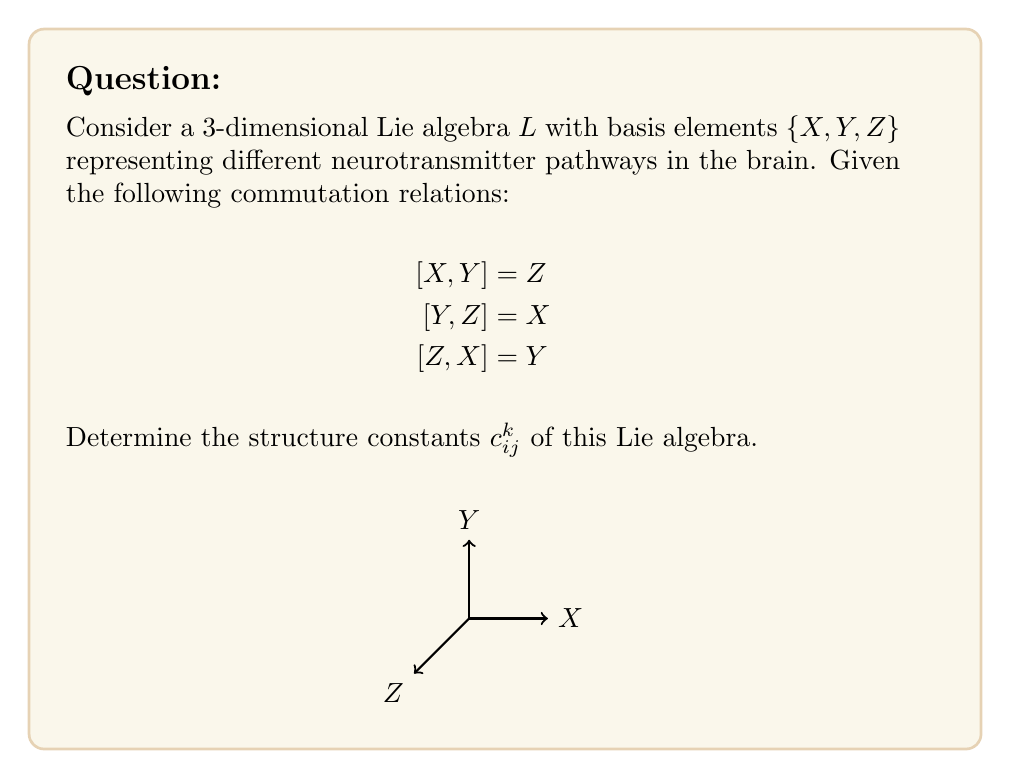Show me your answer to this math problem. To find the structure constants, we follow these steps:

1) The structure constants $c_{ij}^k$ are defined by the equation:

   $$[e_i, e_j] = \sum_k c_{ij}^k e_k$$

   where $e_i, e_j, e_k$ are basis elements.

2) In our case, we have $e_1 = X$, $e_2 = Y$, and $e_3 = Z$.

3) Let's analyze each commutation relation:

   a) $[X, Y] = Z$ implies $c_{12}^3 = 1$ and $c_{12}^1 = c_{12}^2 = 0$
   b) $[Y, Z] = X$ implies $c_{23}^1 = 1$ and $c_{23}^2 = c_{23}^3 = 0$
   c) $[Z, X] = Y$ implies $c_{31}^2 = 1$ and $c_{31}^1 = c_{31}^3 = 0$

4) Note that $c_{ij}^k = -c_{ji}^k$ due to the antisymmetry of the Lie bracket. So:

   d) $c_{21}^3 = -1$, $c_{32}^1 = -1$, $c_{13}^2 = -1$

5) All other structure constants are zero.

6) We can represent these structure constants in a 3x3x3 array:

   $$c_{ij}^k = \begin{bmatrix}
   0 & 0 & -1 \\
   0 & 0 & 1 \\
   1 & -1 & 0
   \end{bmatrix} \text{ (for k = 1)},
   \begin{bmatrix}
   0 & 0 & 1 \\
   0 & 0 & 0 \\
   -1 & 0 & 0
   \end{bmatrix} \text{ (for k = 2)},
   \begin{bmatrix}
   0 & 1 & 0 \\
   -1 & 0 & 0 \\
   0 & 0 & 0
   \end{bmatrix} \text{ (for k = 3)}$$
Answer: $c_{12}^3 = c_{23}^1 = c_{31}^2 = 1$, $c_{21}^3 = c_{32}^1 = c_{13}^2 = -1$, all others zero. 